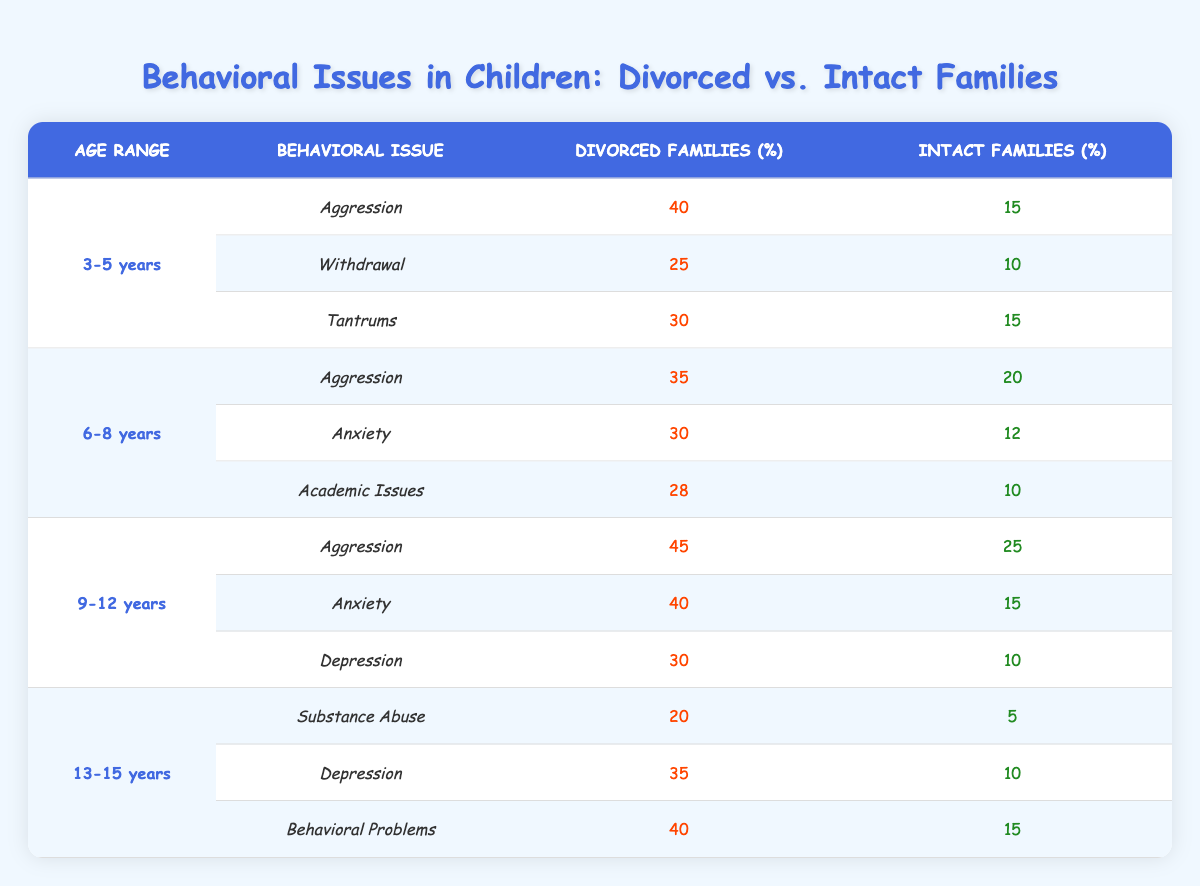What behavioral issue has the highest percentage in children from divorced families aged 3-5 years? In the age range of 3-5 years, the behavioral issues listed are Aggression (40), Withdrawal (25), and Tantrums (30). Comparing these values, Aggression has the highest percentage at 40.
Answer: Aggression What percentage of children from intact families aged 9-12 years show anxiety issues? In the age range of 9-12 years for intact families, the percentage of children with anxiety issues is 15.
Answer: 15 Is the percentage of aggression in divorced families higher for the age range 9-12 years compared to 6-8 years? For the 9-12 years age range, the aggression percentage in divorced families is 45. For the 6-8 years age range, it is 35. Since 45 is greater than 35, the statement is true.
Answer: Yes How many more children in divorced families aged 9-12 years show behavioral problems compared to intact families? In the age range of 9-12 years, the number of children with behavioral problems in divorced families is 30, whereas in intact families, it is 10. The difference is 30 - 10 = 20.
Answer: 20 What is the total percentage of behavioral issues reported for children from divorced families aged 13-15 years? For the age range 13-15 years in divorced families, the behavioral issues reported are Substance Abuse (20), Depression (35), and Behavioral Problems (40). Totaling these gives 20 + 35 + 40 = 95.
Answer: 95 Which behavioral issue is reported more often in divorced families: aggression in the age range 6-8 years or anxiety in the age range 3-5 years? In the age range of 6-8 years, aggression in divorced families is 35, while in the age range of 3-5 years, anxiety is not listed, but Tantrums (30) and Withdrawal (25) do not exceed aggression. Therefore, aggression (35) is higher.
Answer: Aggression What is the average percentage of anxiety issues across all age ranges for children from divorced families? The anxiety percentages in divorced families are: 30 (age 6-8) and 40 (age 9-12). There is no data for ages 3-5 and 13-15. The average is (30 + 40) / 2 = 35.
Answer: 35 Are there more children showing tantrums in divorced families aged 3-5 years than academic issues in intact families aged 6-8 years? For divorced families aged 3-5 years, the percentage for tantrums is 30, while for intact families aged 6-8 years, academic issues show 10. Since 30 > 10, this statement is true.
Answer: Yes 